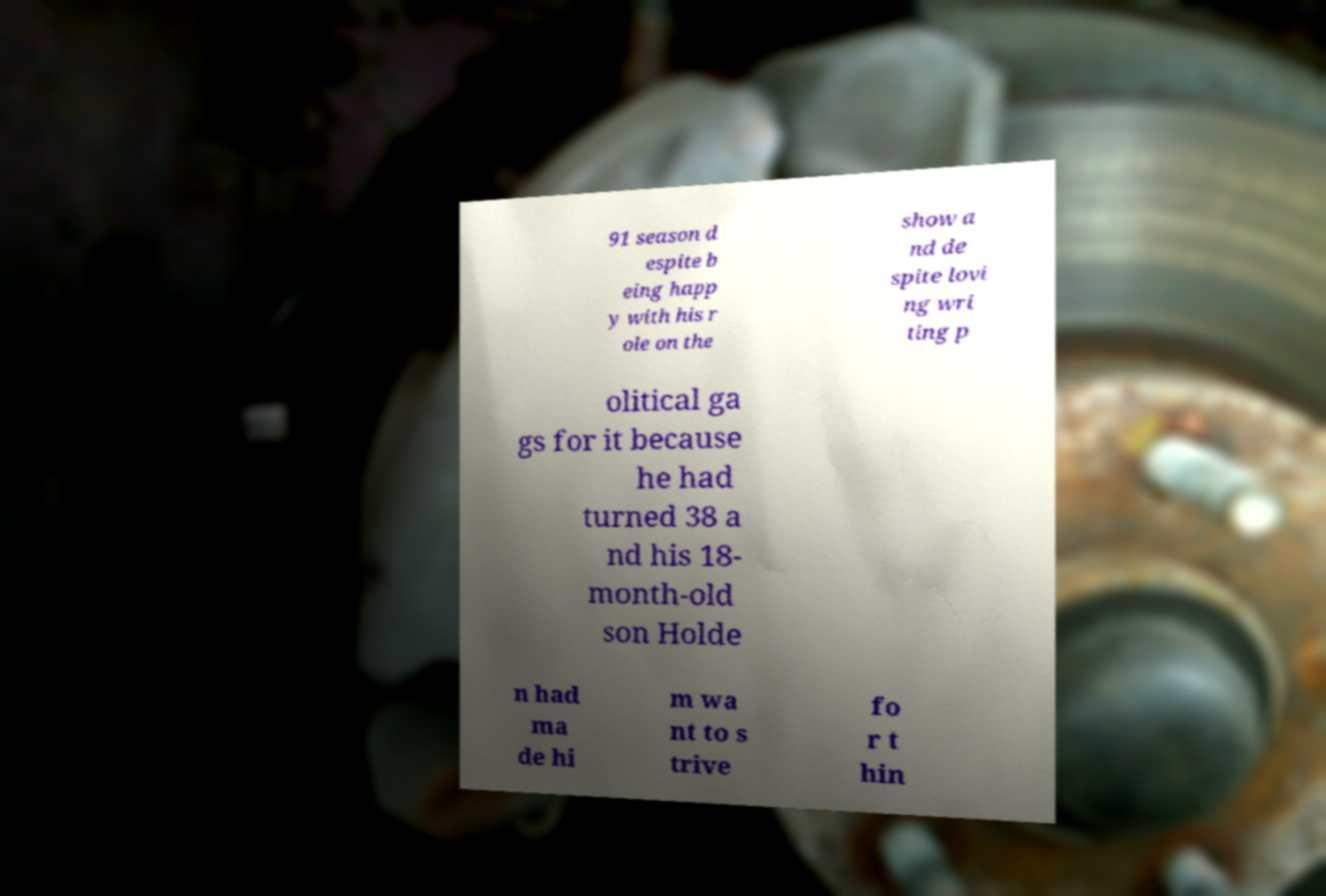Could you assist in decoding the text presented in this image and type it out clearly? 91 season d espite b eing happ y with his r ole on the show a nd de spite lovi ng wri ting p olitical ga gs for it because he had turned 38 a nd his 18- month-old son Holde n had ma de hi m wa nt to s trive fo r t hin 